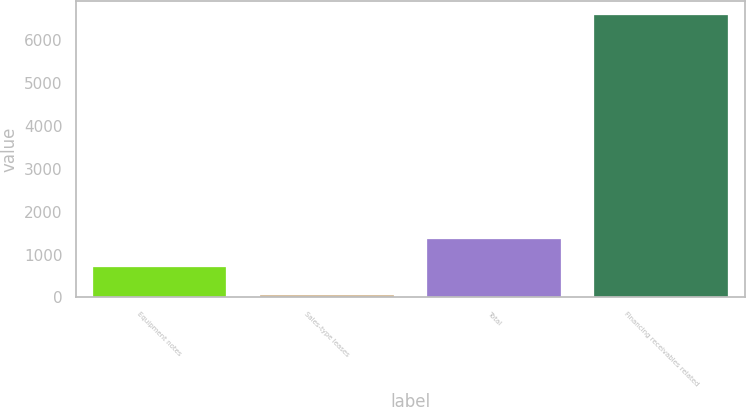Convert chart. <chart><loc_0><loc_0><loc_500><loc_500><bar_chart><fcel>Equipment notes<fcel>Sales-type leases<fcel>Total<fcel>Financing receivables related<nl><fcel>714.4<fcel>61<fcel>1367.8<fcel>6595<nl></chart> 